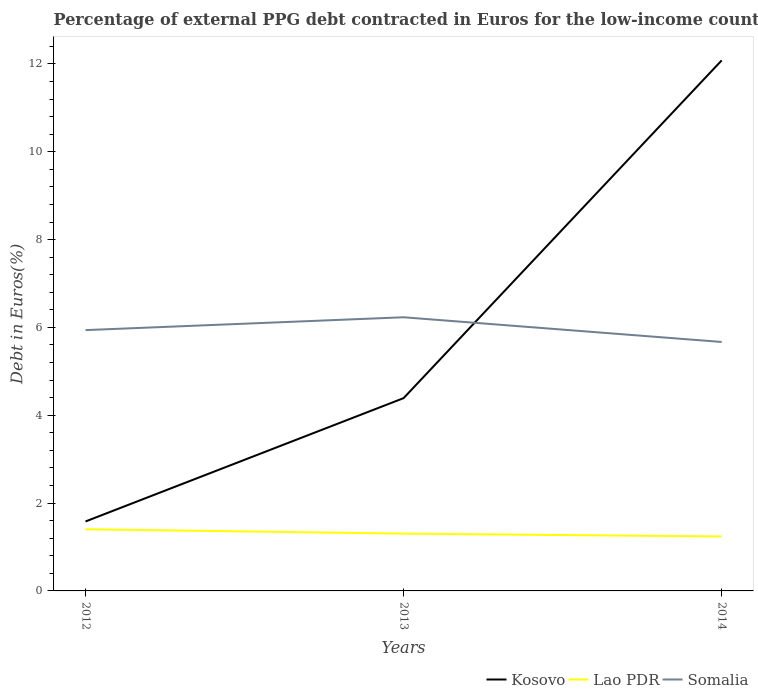How many different coloured lines are there?
Offer a very short reply. 3. Does the line corresponding to Kosovo intersect with the line corresponding to Lao PDR?
Keep it short and to the point. No. Is the number of lines equal to the number of legend labels?
Provide a succinct answer. Yes. Across all years, what is the maximum percentage of external PPG debt contracted in Euros in Lao PDR?
Your answer should be very brief. 1.24. What is the total percentage of external PPG debt contracted in Euros in Somalia in the graph?
Provide a short and direct response. 0.27. What is the difference between the highest and the second highest percentage of external PPG debt contracted in Euros in Somalia?
Your response must be concise. 0.56. What is the difference between the highest and the lowest percentage of external PPG debt contracted in Euros in Kosovo?
Provide a succinct answer. 1. Is the percentage of external PPG debt contracted in Euros in Lao PDR strictly greater than the percentage of external PPG debt contracted in Euros in Somalia over the years?
Your response must be concise. Yes. How many lines are there?
Your response must be concise. 3. What is the difference between two consecutive major ticks on the Y-axis?
Give a very brief answer. 2. Does the graph contain grids?
Ensure brevity in your answer.  No. How many legend labels are there?
Make the answer very short. 3. What is the title of the graph?
Offer a very short reply. Percentage of external PPG debt contracted in Euros for the low-income countries. What is the label or title of the Y-axis?
Keep it short and to the point. Debt in Euros(%). What is the Debt in Euros(%) in Kosovo in 2012?
Offer a very short reply. 1.58. What is the Debt in Euros(%) of Lao PDR in 2012?
Provide a succinct answer. 1.4. What is the Debt in Euros(%) in Somalia in 2012?
Ensure brevity in your answer.  5.94. What is the Debt in Euros(%) of Kosovo in 2013?
Your response must be concise. 4.39. What is the Debt in Euros(%) of Lao PDR in 2013?
Your response must be concise. 1.3. What is the Debt in Euros(%) in Somalia in 2013?
Provide a succinct answer. 6.23. What is the Debt in Euros(%) of Kosovo in 2014?
Make the answer very short. 12.08. What is the Debt in Euros(%) in Lao PDR in 2014?
Offer a terse response. 1.24. What is the Debt in Euros(%) in Somalia in 2014?
Provide a short and direct response. 5.67. Across all years, what is the maximum Debt in Euros(%) of Kosovo?
Your answer should be very brief. 12.08. Across all years, what is the maximum Debt in Euros(%) in Lao PDR?
Provide a succinct answer. 1.4. Across all years, what is the maximum Debt in Euros(%) of Somalia?
Your answer should be compact. 6.23. Across all years, what is the minimum Debt in Euros(%) in Kosovo?
Offer a terse response. 1.58. Across all years, what is the minimum Debt in Euros(%) in Lao PDR?
Make the answer very short. 1.24. Across all years, what is the minimum Debt in Euros(%) of Somalia?
Your answer should be compact. 5.67. What is the total Debt in Euros(%) of Kosovo in the graph?
Your response must be concise. 18.05. What is the total Debt in Euros(%) in Lao PDR in the graph?
Ensure brevity in your answer.  3.95. What is the total Debt in Euros(%) in Somalia in the graph?
Provide a succinct answer. 17.84. What is the difference between the Debt in Euros(%) in Kosovo in 2012 and that in 2013?
Provide a succinct answer. -2.81. What is the difference between the Debt in Euros(%) in Lao PDR in 2012 and that in 2013?
Make the answer very short. 0.1. What is the difference between the Debt in Euros(%) of Somalia in 2012 and that in 2013?
Ensure brevity in your answer.  -0.29. What is the difference between the Debt in Euros(%) in Kosovo in 2012 and that in 2014?
Keep it short and to the point. -10.5. What is the difference between the Debt in Euros(%) of Lao PDR in 2012 and that in 2014?
Your response must be concise. 0.16. What is the difference between the Debt in Euros(%) in Somalia in 2012 and that in 2014?
Offer a terse response. 0.27. What is the difference between the Debt in Euros(%) of Kosovo in 2013 and that in 2014?
Your response must be concise. -7.69. What is the difference between the Debt in Euros(%) in Lao PDR in 2013 and that in 2014?
Give a very brief answer. 0.07. What is the difference between the Debt in Euros(%) in Somalia in 2013 and that in 2014?
Offer a very short reply. 0.56. What is the difference between the Debt in Euros(%) of Kosovo in 2012 and the Debt in Euros(%) of Lao PDR in 2013?
Offer a very short reply. 0.28. What is the difference between the Debt in Euros(%) of Kosovo in 2012 and the Debt in Euros(%) of Somalia in 2013?
Offer a very short reply. -4.65. What is the difference between the Debt in Euros(%) in Lao PDR in 2012 and the Debt in Euros(%) in Somalia in 2013?
Keep it short and to the point. -4.83. What is the difference between the Debt in Euros(%) of Kosovo in 2012 and the Debt in Euros(%) of Lao PDR in 2014?
Provide a succinct answer. 0.34. What is the difference between the Debt in Euros(%) of Kosovo in 2012 and the Debt in Euros(%) of Somalia in 2014?
Your answer should be very brief. -4.09. What is the difference between the Debt in Euros(%) in Lao PDR in 2012 and the Debt in Euros(%) in Somalia in 2014?
Provide a succinct answer. -4.26. What is the difference between the Debt in Euros(%) in Kosovo in 2013 and the Debt in Euros(%) in Lao PDR in 2014?
Your answer should be very brief. 3.15. What is the difference between the Debt in Euros(%) of Kosovo in 2013 and the Debt in Euros(%) of Somalia in 2014?
Make the answer very short. -1.28. What is the difference between the Debt in Euros(%) of Lao PDR in 2013 and the Debt in Euros(%) of Somalia in 2014?
Your response must be concise. -4.36. What is the average Debt in Euros(%) of Kosovo per year?
Your answer should be compact. 6.02. What is the average Debt in Euros(%) in Lao PDR per year?
Give a very brief answer. 1.32. What is the average Debt in Euros(%) in Somalia per year?
Your answer should be very brief. 5.95. In the year 2012, what is the difference between the Debt in Euros(%) of Kosovo and Debt in Euros(%) of Lao PDR?
Make the answer very short. 0.18. In the year 2012, what is the difference between the Debt in Euros(%) in Kosovo and Debt in Euros(%) in Somalia?
Make the answer very short. -4.36. In the year 2012, what is the difference between the Debt in Euros(%) in Lao PDR and Debt in Euros(%) in Somalia?
Your response must be concise. -4.53. In the year 2013, what is the difference between the Debt in Euros(%) of Kosovo and Debt in Euros(%) of Lao PDR?
Make the answer very short. 3.09. In the year 2013, what is the difference between the Debt in Euros(%) of Kosovo and Debt in Euros(%) of Somalia?
Make the answer very short. -1.84. In the year 2013, what is the difference between the Debt in Euros(%) of Lao PDR and Debt in Euros(%) of Somalia?
Offer a terse response. -4.93. In the year 2014, what is the difference between the Debt in Euros(%) in Kosovo and Debt in Euros(%) in Lao PDR?
Offer a terse response. 10.84. In the year 2014, what is the difference between the Debt in Euros(%) in Kosovo and Debt in Euros(%) in Somalia?
Ensure brevity in your answer.  6.41. In the year 2014, what is the difference between the Debt in Euros(%) of Lao PDR and Debt in Euros(%) of Somalia?
Your response must be concise. -4.43. What is the ratio of the Debt in Euros(%) of Kosovo in 2012 to that in 2013?
Offer a very short reply. 0.36. What is the ratio of the Debt in Euros(%) in Lao PDR in 2012 to that in 2013?
Your answer should be compact. 1.08. What is the ratio of the Debt in Euros(%) of Somalia in 2012 to that in 2013?
Make the answer very short. 0.95. What is the ratio of the Debt in Euros(%) in Kosovo in 2012 to that in 2014?
Your answer should be compact. 0.13. What is the ratio of the Debt in Euros(%) of Lao PDR in 2012 to that in 2014?
Your response must be concise. 1.13. What is the ratio of the Debt in Euros(%) in Somalia in 2012 to that in 2014?
Keep it short and to the point. 1.05. What is the ratio of the Debt in Euros(%) in Kosovo in 2013 to that in 2014?
Ensure brevity in your answer.  0.36. What is the ratio of the Debt in Euros(%) of Lao PDR in 2013 to that in 2014?
Provide a short and direct response. 1.05. What is the ratio of the Debt in Euros(%) of Somalia in 2013 to that in 2014?
Ensure brevity in your answer.  1.1. What is the difference between the highest and the second highest Debt in Euros(%) in Kosovo?
Offer a terse response. 7.69. What is the difference between the highest and the second highest Debt in Euros(%) in Lao PDR?
Keep it short and to the point. 0.1. What is the difference between the highest and the second highest Debt in Euros(%) of Somalia?
Offer a very short reply. 0.29. What is the difference between the highest and the lowest Debt in Euros(%) in Kosovo?
Keep it short and to the point. 10.5. What is the difference between the highest and the lowest Debt in Euros(%) of Lao PDR?
Your answer should be very brief. 0.16. What is the difference between the highest and the lowest Debt in Euros(%) of Somalia?
Provide a succinct answer. 0.56. 